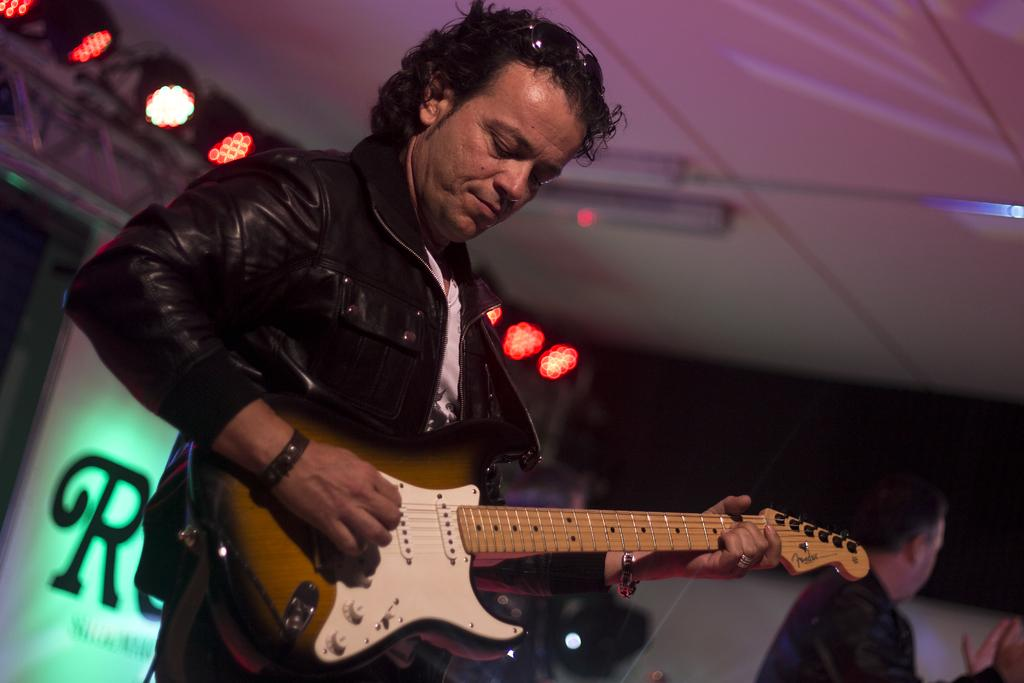What is the man in the image doing? The man is playing the guitar. What type of clothing is the man wearing? The man is wearing a coat and shirt. What can be seen behind the man? There is a banner behind the man. What type of lighting is present in the image? Disco lights are present in the image. What type of screw is holding the veil in place in the image? There is no veil or screw present in the image. How many hairs can be seen on the man's head in the image? The image does not provide enough detail to count individual hairs on the man's head. 